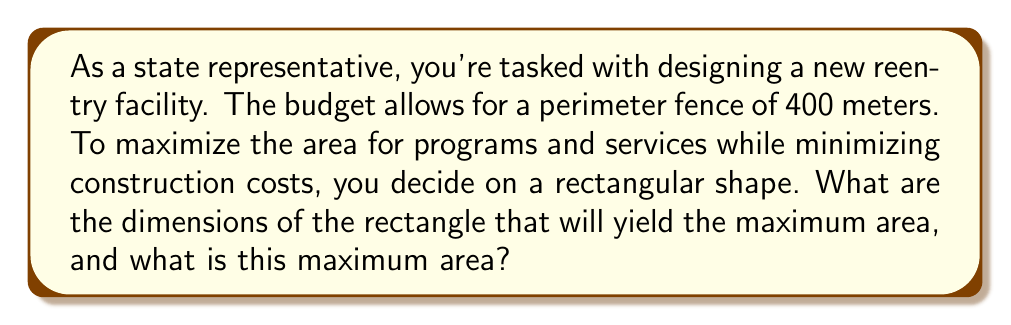Show me your answer to this math problem. Let's approach this step-by-step:

1) Let the width of the rectangle be $w$ and the length be $l$.

2) Given the perimeter is 400 meters, we can write:
   $2w + 2l = 400$
   $w + l = 200$
   $l = 200 - w$

3) The area $A$ of the rectangle is given by:
   $A = w * l = w(200-w) = 200w - w^2$

4) To find the maximum area, we need to find where the derivative of $A$ with respect to $w$ is zero:
   $\frac{dA}{dw} = 200 - 2w$

5) Setting this equal to zero:
   $200 - 2w = 0$
   $2w = 200$
   $w = 100$

6) Since $l = 200 - w$, we find that $l$ is also 100.

7) To confirm this is a maximum (not a minimum), we can check the second derivative:
   $\frac{d^2A}{dw^2} = -2$, which is negative, confirming a maximum.

8) The maximum area is therefore:
   $A = 100 * 100 = 10,000$ square meters

[asy]
unitsize(0.05cm);
draw((0,0)--(100,0)--(100,100)--(0,100)--cycle);
label("100 m", (50,0), S);
label("100 m", (0,50), W);
label("Area = 10,000 sq m", (50,50));
[/asy]
Answer: 100m x 100m rectangle; 10,000 sq m 